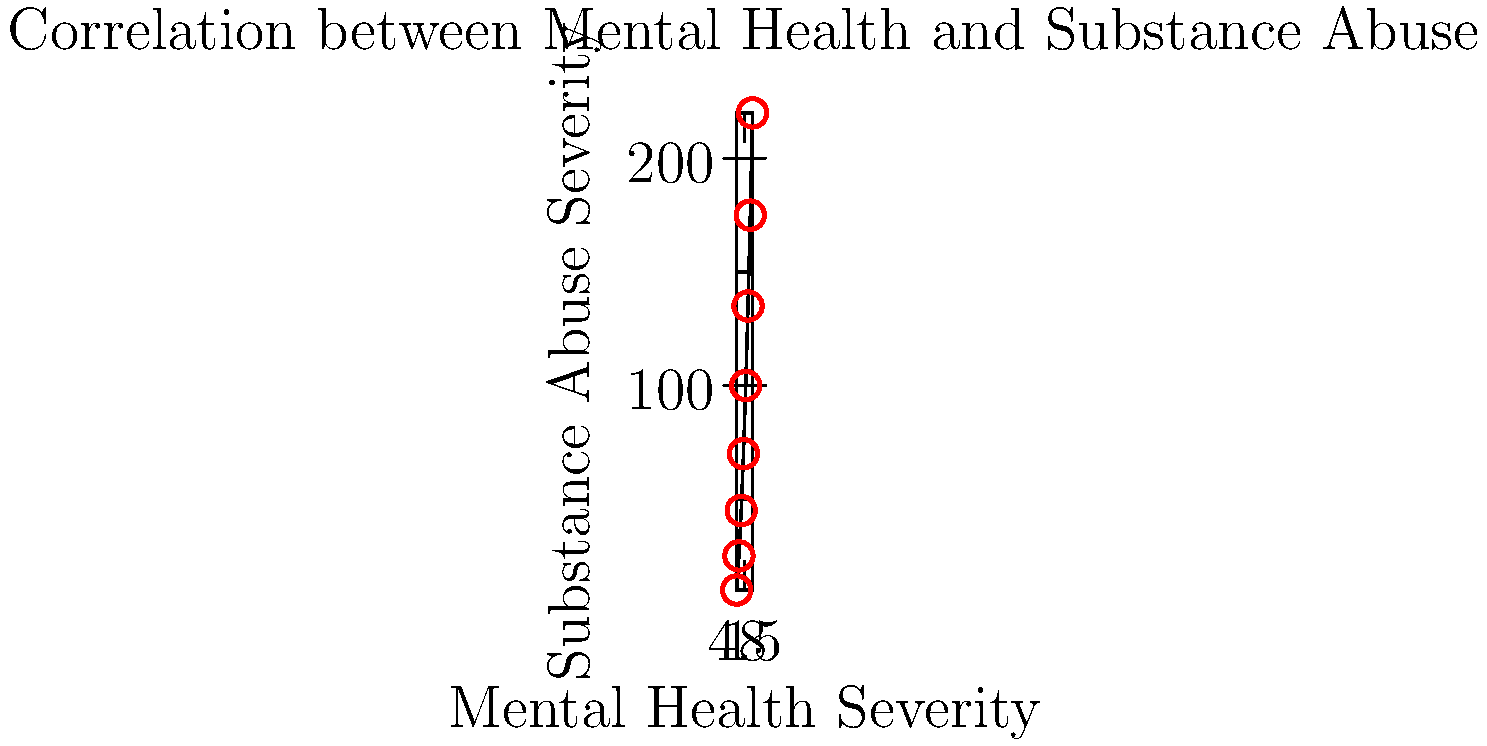Based on the scatter plot showing the correlation between mental health disorders and substance abuse severity, what type of relationship is observed between these two variables? To determine the relationship between mental health disorders and substance abuse severity, we need to analyze the pattern of data points in the scatter plot:

1. Observe the overall trend: As we move from left to right (increasing mental health severity), the data points tend to move upward (increasing substance abuse severity).

2. Assess the pattern: The points form a clear upward trend, with no significant deviations or curves.

3. Evaluate the consistency: The relationship appears to be consistent throughout the range of data points, with no clear clusters or outliers.

4. Consider the slope: The line of best fit (though not drawn) would have a positive slope, indicating a positive relationship.

5. Analyze the strength: The points closely follow the trend, suggesting a strong relationship.

6. Determine linearity: The points roughly form a straight line, indicating a linear relationship.

Given these observations, we can conclude that there is a strong, positive, linear relationship between mental health disorder severity and substance abuse severity.
Answer: Strong positive linear relationship 